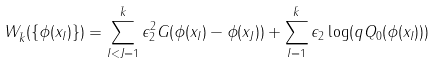<formula> <loc_0><loc_0><loc_500><loc_500>W _ { \bar { k } } ( \{ \phi ( x _ { I } ) \} ) = \sum _ { I < J = 1 } ^ { \bar { k } } \epsilon _ { 2 } ^ { 2 } G ( \phi ( x _ { I } ) - \phi ( x _ { J } ) ) + \sum _ { I = 1 } ^ { \bar { k } } \epsilon _ { 2 } \log ( q Q _ { 0 } ( \phi ( x _ { I } ) ) )</formula> 